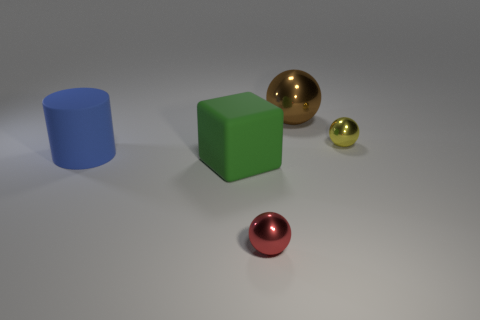There is a metal ball that is behind the large green rubber object and to the left of the small yellow metal thing; how big is it?
Offer a very short reply. Large. There is a red metal thing that is the same shape as the big brown shiny thing; what is its size?
Your answer should be very brief. Small. Is the material of the small thing that is in front of the blue rubber thing the same as the small thing that is behind the large blue object?
Your answer should be compact. Yes. How many matte things are small balls or large balls?
Make the answer very short. 0. What material is the sphere that is in front of the tiny shiny object behind the thing in front of the large green object made of?
Offer a very short reply. Metal. There is a small thing that is behind the block; is its shape the same as the small thing to the left of the small yellow metal object?
Your response must be concise. Yes. There is a metallic sphere in front of the tiny metal sphere that is right of the big brown metallic sphere; what color is it?
Provide a short and direct response. Red. What number of spheres are large things or large brown metal things?
Your answer should be compact. 1. How many brown shiny spheres are to the left of the metallic ball that is in front of the tiny yellow sphere right of the big cylinder?
Offer a very short reply. 0. Are there any tiny red balls that have the same material as the green thing?
Provide a succinct answer. No. 